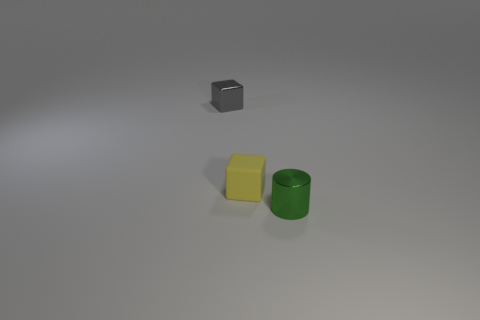Add 3 tiny gray shiny blocks. How many objects exist? 6 Subtract all yellow blocks. How many blocks are left? 1 Subtract all blocks. How many objects are left? 1 Add 1 gray cubes. How many gray cubes are left? 2 Add 2 cyan metallic things. How many cyan metallic things exist? 2 Subtract 1 green cylinders. How many objects are left? 2 Subtract 1 blocks. How many blocks are left? 1 Subtract all gray blocks. Subtract all blue balls. How many blocks are left? 1 Subtract all tiny yellow cubes. Subtract all large rubber objects. How many objects are left? 2 